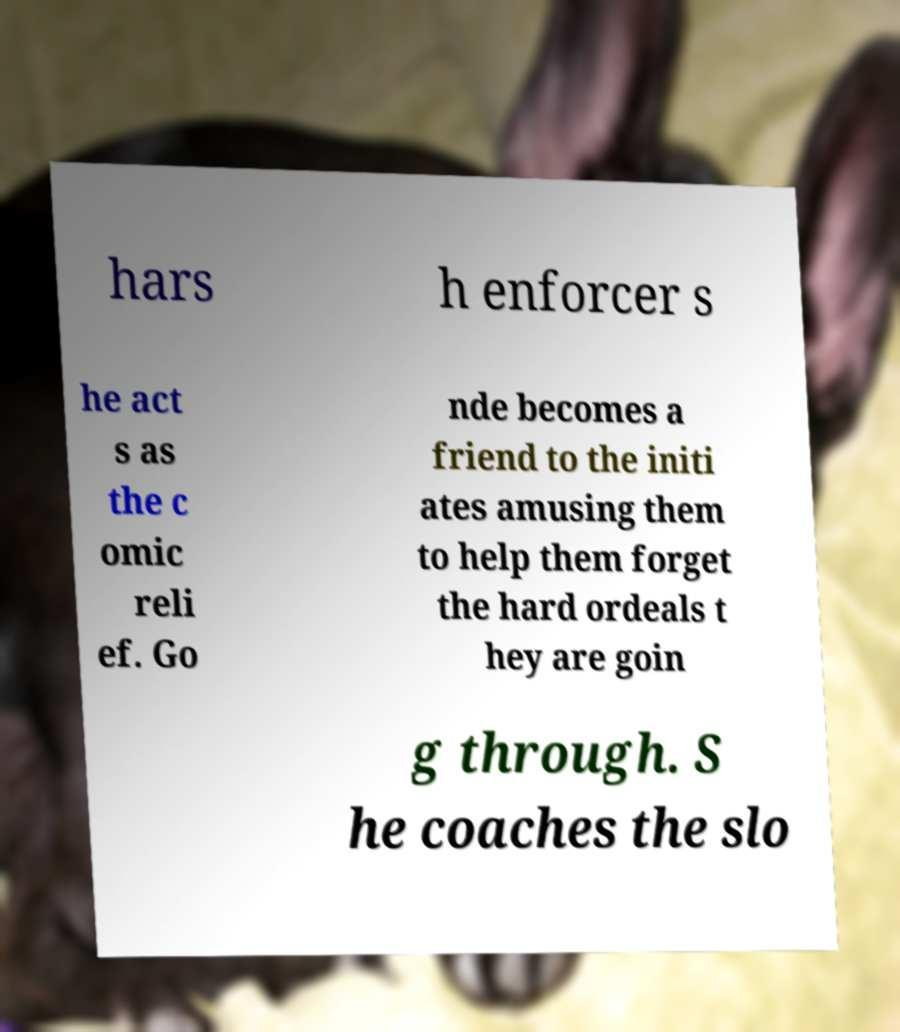Could you extract and type out the text from this image? hars h enforcer s he act s as the c omic reli ef. Go nde becomes a friend to the initi ates amusing them to help them forget the hard ordeals t hey are goin g through. S he coaches the slo 